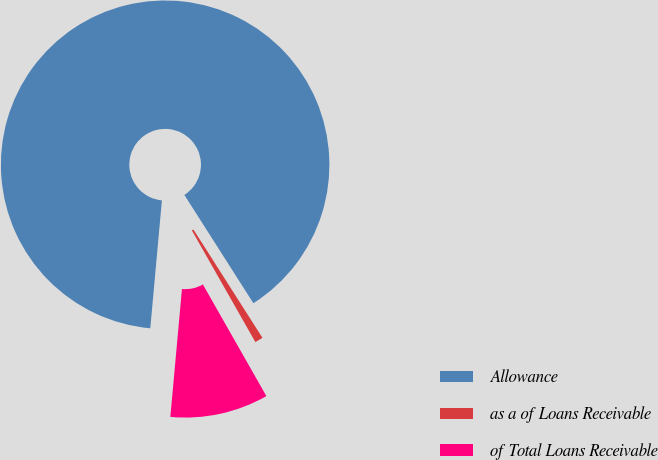Convert chart to OTSL. <chart><loc_0><loc_0><loc_500><loc_500><pie_chart><fcel>Allowance<fcel>as a of Loans Receivable<fcel>of Total Loans Receivable<nl><fcel>89.53%<fcel>0.8%<fcel>9.67%<nl></chart> 